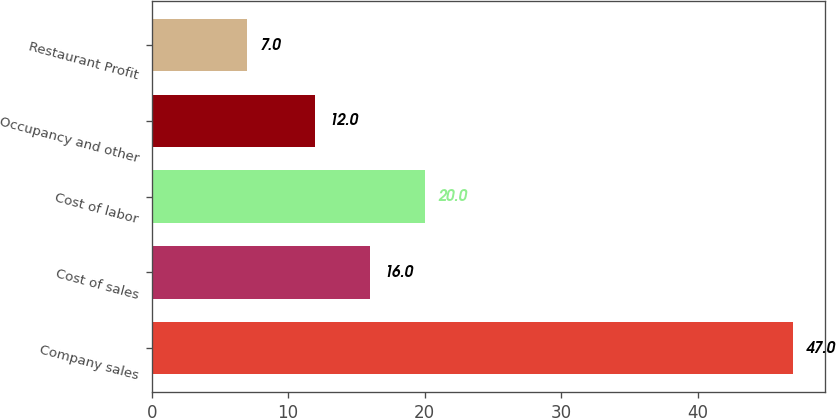Convert chart. <chart><loc_0><loc_0><loc_500><loc_500><bar_chart><fcel>Company sales<fcel>Cost of sales<fcel>Cost of labor<fcel>Occupancy and other<fcel>Restaurant Profit<nl><fcel>47<fcel>16<fcel>20<fcel>12<fcel>7<nl></chart> 